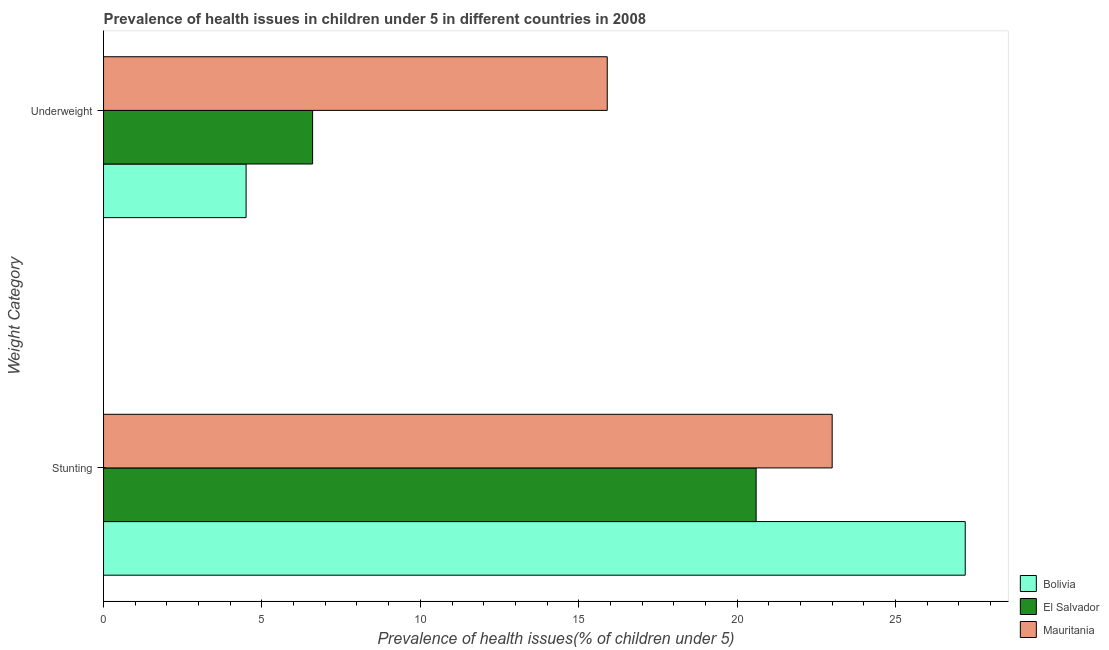How many different coloured bars are there?
Your answer should be very brief. 3. How many bars are there on the 1st tick from the bottom?
Give a very brief answer. 3. What is the label of the 1st group of bars from the top?
Your answer should be very brief. Underweight. What is the percentage of stunted children in Mauritania?
Make the answer very short. 23. Across all countries, what is the maximum percentage of underweight children?
Ensure brevity in your answer.  15.9. Across all countries, what is the minimum percentage of stunted children?
Your response must be concise. 20.6. In which country was the percentage of underweight children maximum?
Make the answer very short. Mauritania. What is the total percentage of underweight children in the graph?
Make the answer very short. 27. What is the difference between the percentage of stunted children in Mauritania and that in Bolivia?
Make the answer very short. -4.2. What is the difference between the percentage of stunted children in Bolivia and the percentage of underweight children in El Salvador?
Your answer should be compact. 20.6. What is the average percentage of stunted children per country?
Keep it short and to the point. 23.6. What is the difference between the percentage of stunted children and percentage of underweight children in Bolivia?
Offer a very short reply. 22.7. In how many countries, is the percentage of underweight children greater than 13 %?
Your response must be concise. 1. What is the ratio of the percentage of underweight children in El Salvador to that in Bolivia?
Ensure brevity in your answer.  1.47. What does the 3rd bar from the bottom in Underweight represents?
Your response must be concise. Mauritania. Are all the bars in the graph horizontal?
Your answer should be very brief. Yes. What is the difference between two consecutive major ticks on the X-axis?
Your answer should be very brief. 5. Does the graph contain grids?
Provide a short and direct response. No. Where does the legend appear in the graph?
Offer a terse response. Bottom right. How many legend labels are there?
Your response must be concise. 3. What is the title of the graph?
Offer a terse response. Prevalence of health issues in children under 5 in different countries in 2008. What is the label or title of the X-axis?
Your response must be concise. Prevalence of health issues(% of children under 5). What is the label or title of the Y-axis?
Offer a terse response. Weight Category. What is the Prevalence of health issues(% of children under 5) of Bolivia in Stunting?
Keep it short and to the point. 27.2. What is the Prevalence of health issues(% of children under 5) of El Salvador in Stunting?
Your answer should be compact. 20.6. What is the Prevalence of health issues(% of children under 5) of Mauritania in Stunting?
Your answer should be very brief. 23. What is the Prevalence of health issues(% of children under 5) of Bolivia in Underweight?
Ensure brevity in your answer.  4.5. What is the Prevalence of health issues(% of children under 5) in El Salvador in Underweight?
Provide a short and direct response. 6.6. What is the Prevalence of health issues(% of children under 5) of Mauritania in Underweight?
Give a very brief answer. 15.9. Across all Weight Category, what is the maximum Prevalence of health issues(% of children under 5) of Bolivia?
Your answer should be compact. 27.2. Across all Weight Category, what is the maximum Prevalence of health issues(% of children under 5) in El Salvador?
Make the answer very short. 20.6. Across all Weight Category, what is the minimum Prevalence of health issues(% of children under 5) in Bolivia?
Ensure brevity in your answer.  4.5. Across all Weight Category, what is the minimum Prevalence of health issues(% of children under 5) of El Salvador?
Offer a very short reply. 6.6. Across all Weight Category, what is the minimum Prevalence of health issues(% of children under 5) of Mauritania?
Provide a succinct answer. 15.9. What is the total Prevalence of health issues(% of children under 5) in Bolivia in the graph?
Your answer should be very brief. 31.7. What is the total Prevalence of health issues(% of children under 5) of El Salvador in the graph?
Your answer should be compact. 27.2. What is the total Prevalence of health issues(% of children under 5) in Mauritania in the graph?
Provide a short and direct response. 38.9. What is the difference between the Prevalence of health issues(% of children under 5) in Bolivia in Stunting and that in Underweight?
Ensure brevity in your answer.  22.7. What is the difference between the Prevalence of health issues(% of children under 5) of El Salvador in Stunting and that in Underweight?
Provide a succinct answer. 14. What is the difference between the Prevalence of health issues(% of children under 5) of Mauritania in Stunting and that in Underweight?
Ensure brevity in your answer.  7.1. What is the difference between the Prevalence of health issues(% of children under 5) in Bolivia in Stunting and the Prevalence of health issues(% of children under 5) in El Salvador in Underweight?
Offer a terse response. 20.6. What is the average Prevalence of health issues(% of children under 5) in Bolivia per Weight Category?
Provide a succinct answer. 15.85. What is the average Prevalence of health issues(% of children under 5) of El Salvador per Weight Category?
Your answer should be compact. 13.6. What is the average Prevalence of health issues(% of children under 5) of Mauritania per Weight Category?
Provide a short and direct response. 19.45. What is the difference between the Prevalence of health issues(% of children under 5) of Bolivia and Prevalence of health issues(% of children under 5) of El Salvador in Stunting?
Keep it short and to the point. 6.6. What is the ratio of the Prevalence of health issues(% of children under 5) in Bolivia in Stunting to that in Underweight?
Offer a terse response. 6.04. What is the ratio of the Prevalence of health issues(% of children under 5) of El Salvador in Stunting to that in Underweight?
Offer a terse response. 3.12. What is the ratio of the Prevalence of health issues(% of children under 5) in Mauritania in Stunting to that in Underweight?
Keep it short and to the point. 1.45. What is the difference between the highest and the second highest Prevalence of health issues(% of children under 5) of Bolivia?
Your response must be concise. 22.7. What is the difference between the highest and the second highest Prevalence of health issues(% of children under 5) in El Salvador?
Offer a very short reply. 14. What is the difference between the highest and the lowest Prevalence of health issues(% of children under 5) in Bolivia?
Offer a terse response. 22.7. What is the difference between the highest and the lowest Prevalence of health issues(% of children under 5) in Mauritania?
Provide a short and direct response. 7.1. 